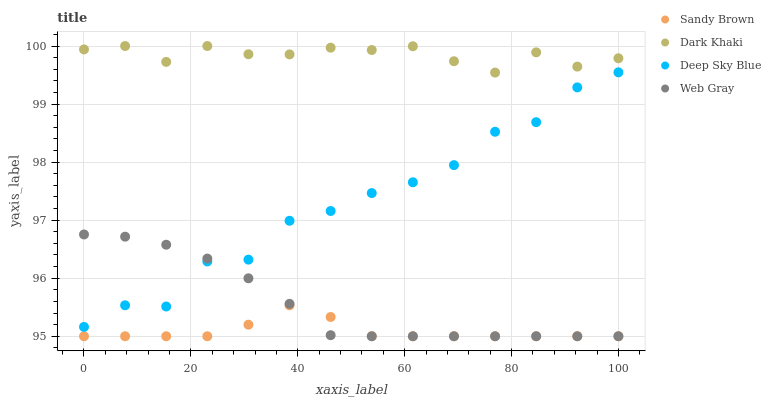Does Sandy Brown have the minimum area under the curve?
Answer yes or no. Yes. Does Dark Khaki have the maximum area under the curve?
Answer yes or no. Yes. Does Web Gray have the minimum area under the curve?
Answer yes or no. No. Does Web Gray have the maximum area under the curve?
Answer yes or no. No. Is Web Gray the smoothest?
Answer yes or no. Yes. Is Deep Sky Blue the roughest?
Answer yes or no. Yes. Is Sandy Brown the smoothest?
Answer yes or no. No. Is Sandy Brown the roughest?
Answer yes or no. No. Does Web Gray have the lowest value?
Answer yes or no. Yes. Does Deep Sky Blue have the lowest value?
Answer yes or no. No. Does Dark Khaki have the highest value?
Answer yes or no. Yes. Does Web Gray have the highest value?
Answer yes or no. No. Is Web Gray less than Dark Khaki?
Answer yes or no. Yes. Is Dark Khaki greater than Sandy Brown?
Answer yes or no. Yes. Does Web Gray intersect Deep Sky Blue?
Answer yes or no. Yes. Is Web Gray less than Deep Sky Blue?
Answer yes or no. No. Is Web Gray greater than Deep Sky Blue?
Answer yes or no. No. Does Web Gray intersect Dark Khaki?
Answer yes or no. No. 